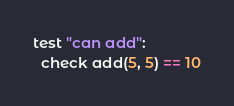<code> <loc_0><loc_0><loc_500><loc_500><_Nim_>test "can add":
  check add(5, 5) == 10
</code> 